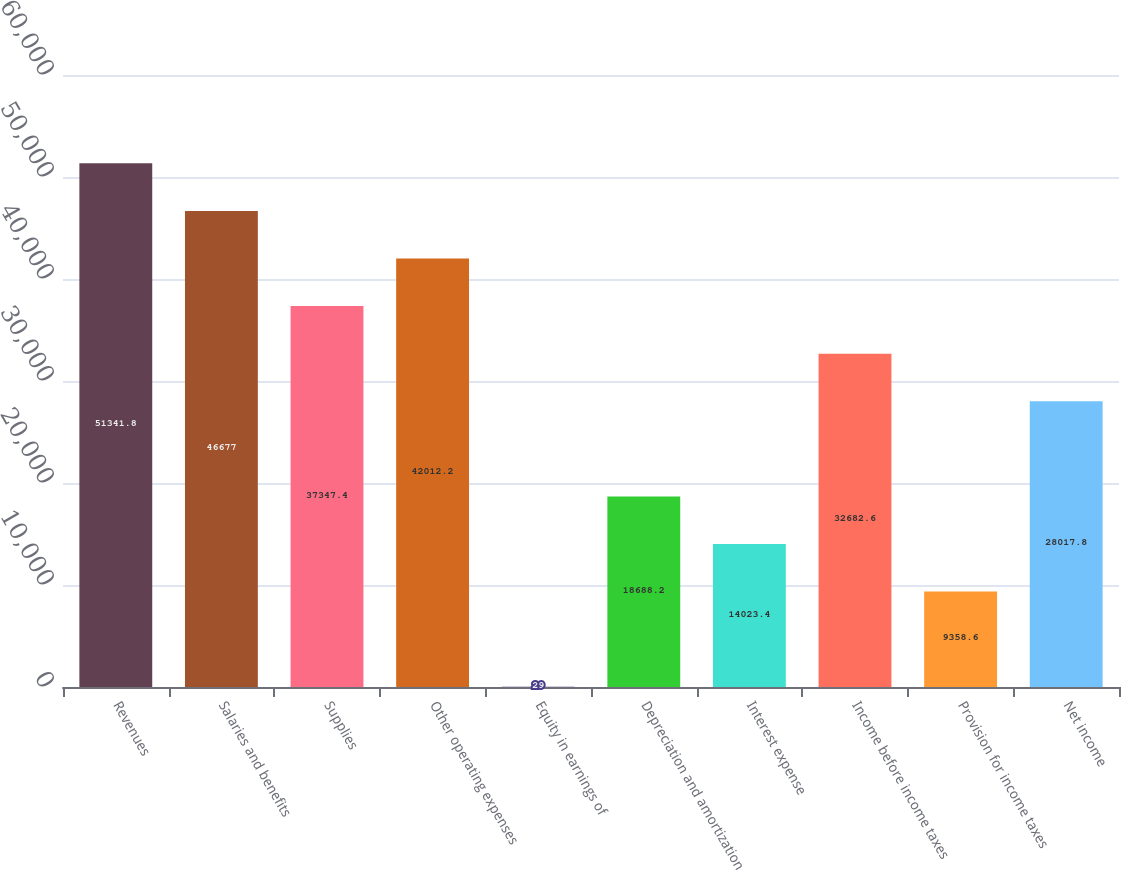Convert chart. <chart><loc_0><loc_0><loc_500><loc_500><bar_chart><fcel>Revenues<fcel>Salaries and benefits<fcel>Supplies<fcel>Other operating expenses<fcel>Equity in earnings of<fcel>Depreciation and amortization<fcel>Interest expense<fcel>Income before income taxes<fcel>Provision for income taxes<fcel>Net income<nl><fcel>51341.8<fcel>46677<fcel>37347.4<fcel>42012.2<fcel>29<fcel>18688.2<fcel>14023.4<fcel>32682.6<fcel>9358.6<fcel>28017.8<nl></chart> 